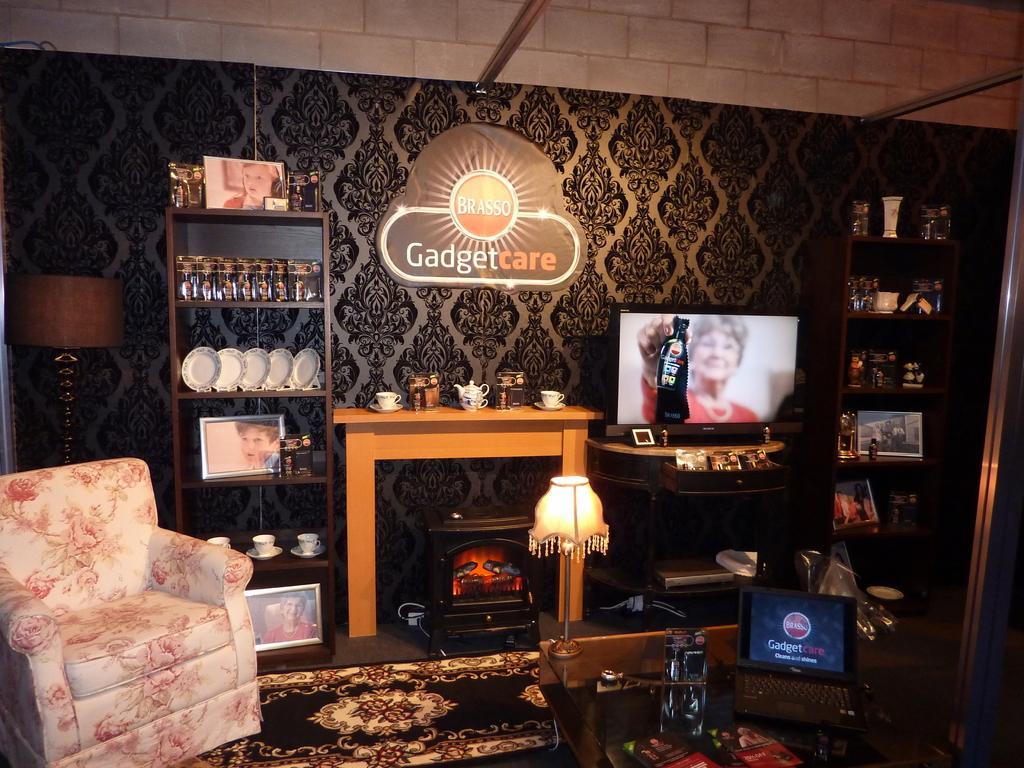Could you give a brief overview of what you see in this image? Laptop on a table,a lamp,TV,some crockery items,another lamp and a sofa chair are arranged in a living room. 